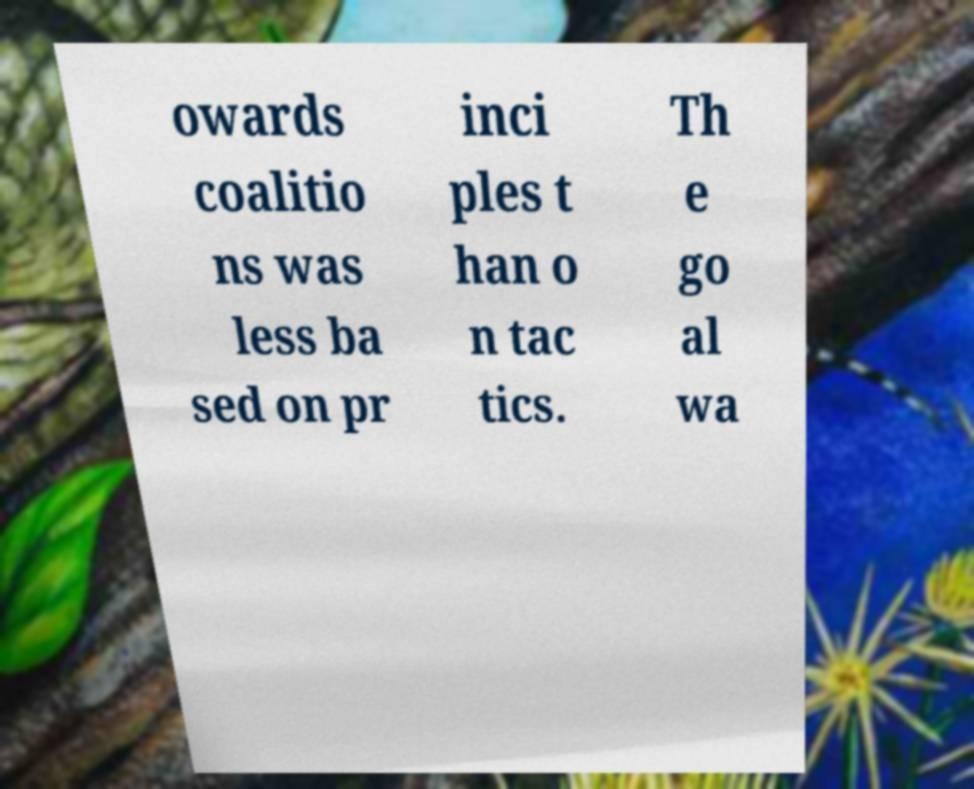Please read and relay the text visible in this image. What does it say? owards coalitio ns was less ba sed on pr inci ples t han o n tac tics. Th e go al wa 